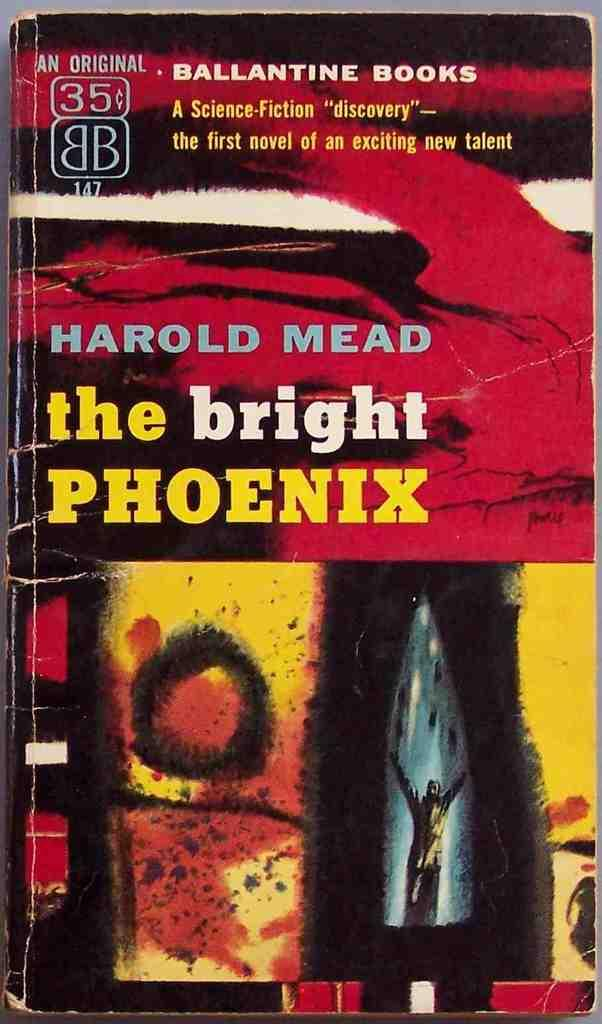<image>
Render a clear and concise summary of the photo. A book titled "the bright PHOENIX" was written by Harold Mead 